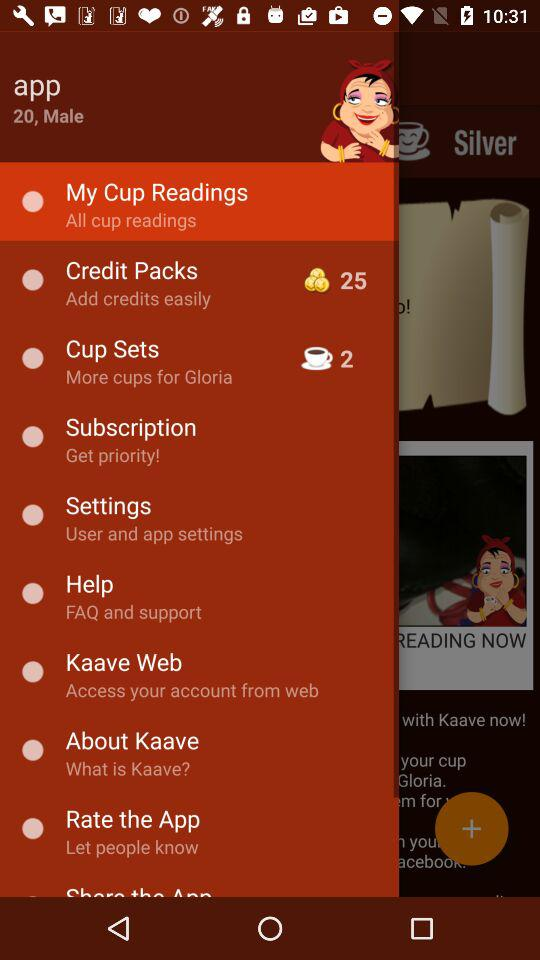How many "Credit Packs" are available? The available "Credit Packs" are 25. 